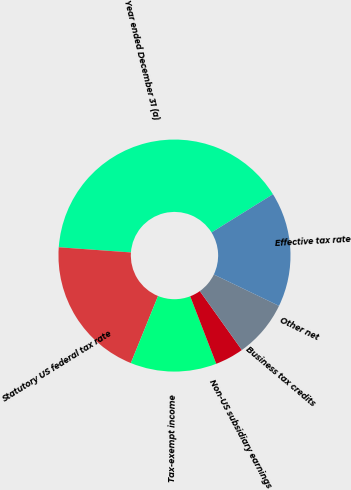Convert chart. <chart><loc_0><loc_0><loc_500><loc_500><pie_chart><fcel>Year ended December 31 (a)<fcel>Statutory US federal tax rate<fcel>Tax-exempt income<fcel>Non-US subsidiary earnings<fcel>Business tax credits<fcel>Other net<fcel>Effective tax rate<nl><fcel>40.0%<fcel>20.0%<fcel>12.0%<fcel>4.0%<fcel>8.0%<fcel>0.0%<fcel>16.0%<nl></chart> 